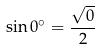<formula> <loc_0><loc_0><loc_500><loc_500>\sin 0 ^ { \circ } = \frac { \sqrt { 0 } } { 2 }</formula> 